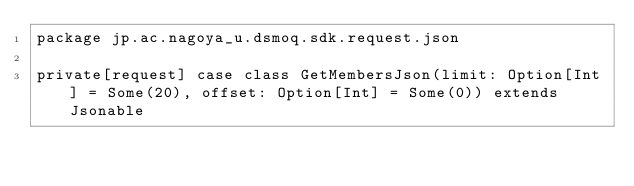<code> <loc_0><loc_0><loc_500><loc_500><_Scala_>package jp.ac.nagoya_u.dsmoq.sdk.request.json

private[request] case class GetMembersJson(limit: Option[Int] = Some(20), offset: Option[Int] = Some(0)) extends Jsonable
</code> 